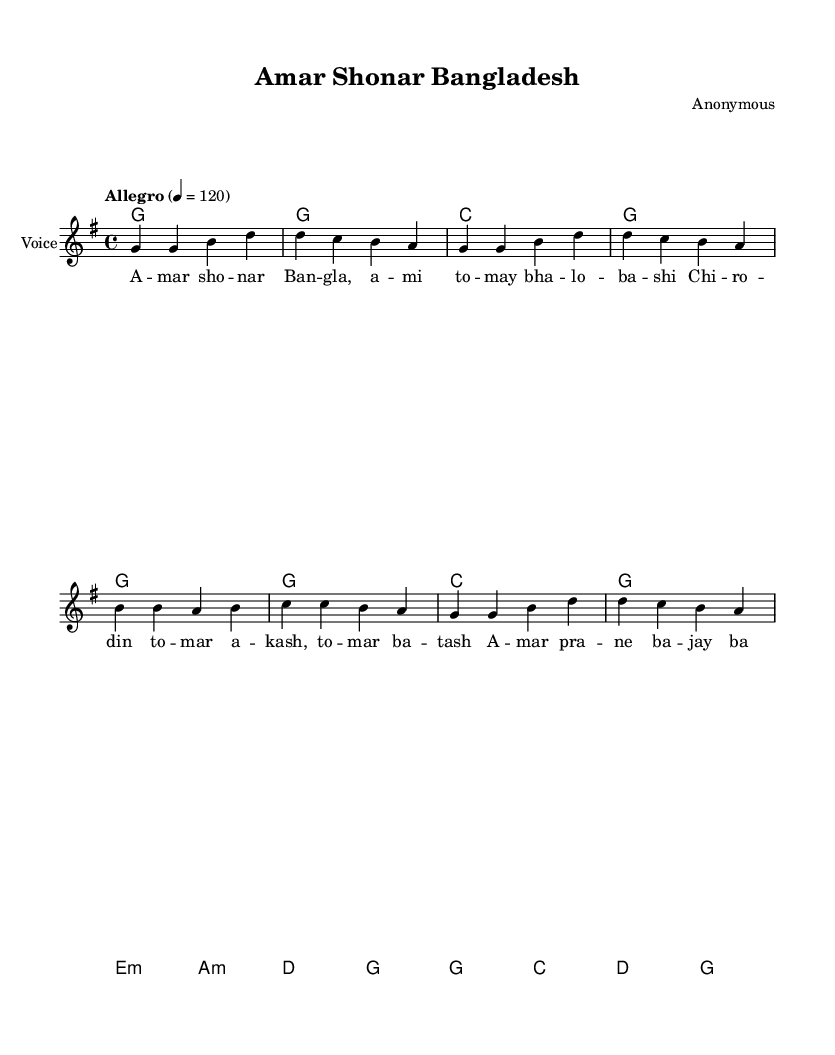What is the key signature of this music? The key signature is G major, which includes one sharp (F#). This can be observed at the beginning of the staff where the sharp is placed.
Answer: G major What is the time signature of this music? The time signature is 4/4, which means there are four beats in each measure and each quarter note gets one beat. This is indicated at the beginning of the score right after the key signature.
Answer: 4/4 What is the tempo marking for this piece? The tempo marking is "Allegro," which indicates a fast and lively pace. This is seen at the start of the score along with the tempo of 120 beats per minute.
Answer: Allegro How many measures are in the melody? There are eight measures in the melody, which can be counted by the vertical lines that separate the measures in the staff. Each set of notes between these lines constitutes one measure.
Answer: 8 What is the initial note of the melody? The initial note of the melody is G, which is the first note in the melody line at the start of the first measure.
Answer: G Identify the type of chords used in the harmonies section. The chords used in the harmonies section are primarily triadic, consisting of the root, third, and fifth notes of the scale. Each measure generally outlines a major or minor triad. This can be seen by examining the specified chord progression in the harmonies section.
Answer: Triadic What is the lyrical theme of the song? The lyrical theme of the song is national pride, celebrating "Amar Shonar Bangladesh" which translates to "My Golden Bengal." This theme is reflected in the lyrics presented below the melody, emphasizing love for the country.
Answer: National pride 